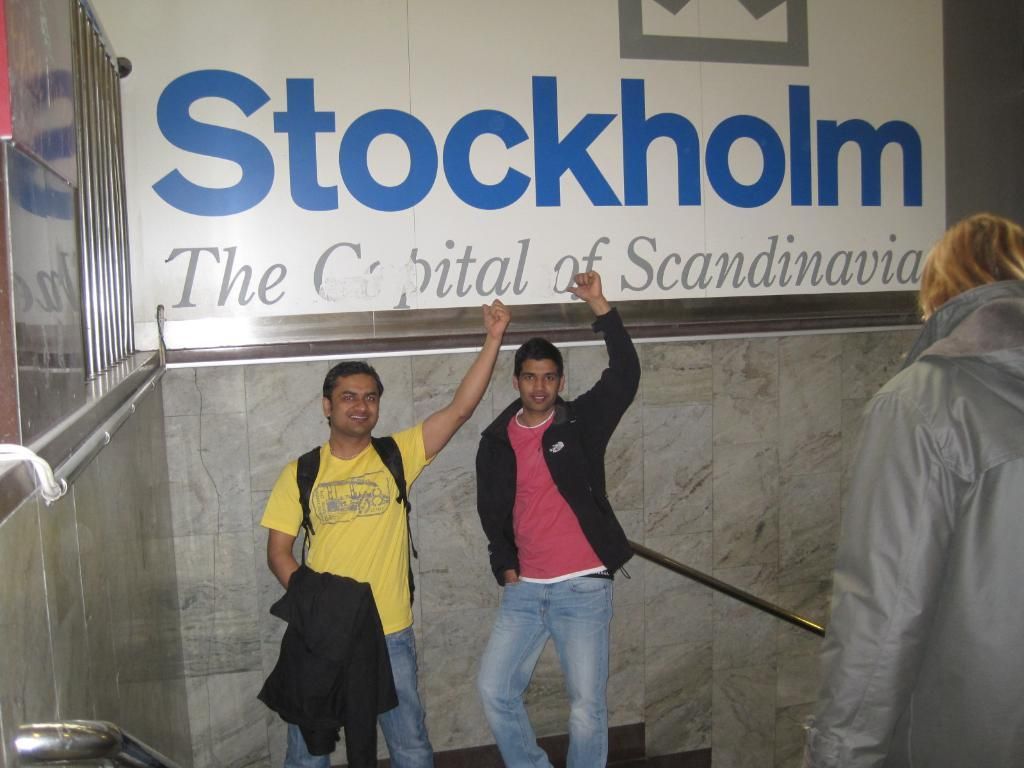What are the people in the image wearing? The persons in the image are wearing clothes. What can be seen in the top left corner of the image? There are grills in the top left corner of the image. What is written or depicted on the wall in the background of the image? There is text on the wall in the background of the image. How does the force of the wind affect the shirts worn by the persons in the image? There is no wind or force mentioned in the image, and the shirts worn by the persons are not affected by any wind. 